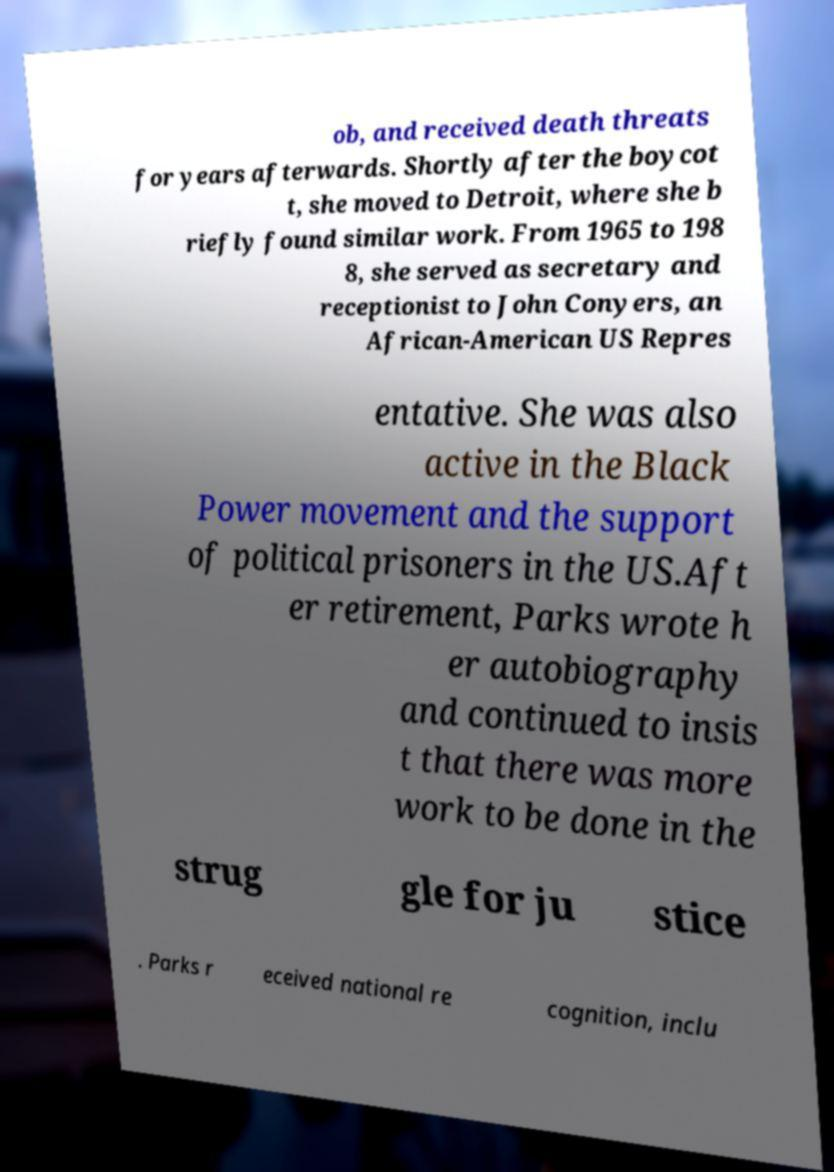Please read and relay the text visible in this image. What does it say? ob, and received death threats for years afterwards. Shortly after the boycot t, she moved to Detroit, where she b riefly found similar work. From 1965 to 198 8, she served as secretary and receptionist to John Conyers, an African-American US Repres entative. She was also active in the Black Power movement and the support of political prisoners in the US.Aft er retirement, Parks wrote h er autobiography and continued to insis t that there was more work to be done in the strug gle for ju stice . Parks r eceived national re cognition, inclu 